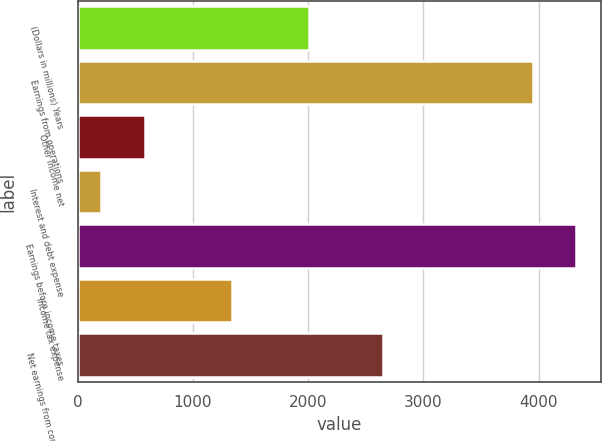Convert chart to OTSL. <chart><loc_0><loc_0><loc_500><loc_500><bar_chart><fcel>(Dollars in millions) Years<fcel>Earnings from operations<fcel>Other income net<fcel>Interest and debt expense<fcel>Earnings before income taxes<fcel>Income tax expense<fcel>Net earnings from continuing<nl><fcel>2008<fcel>3950<fcel>581.3<fcel>202<fcel>4329.3<fcel>1341<fcel>2654<nl></chart> 